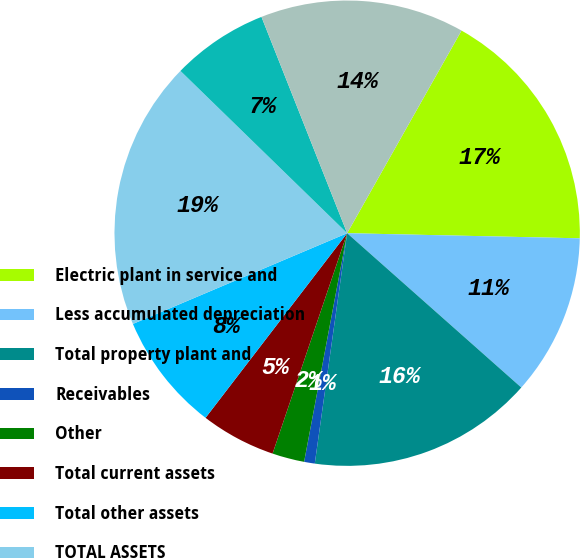Convert chart. <chart><loc_0><loc_0><loc_500><loc_500><pie_chart><fcel>Electric plant in service and<fcel>Less accumulated depreciation<fcel>Total property plant and<fcel>Receivables<fcel>Other<fcel>Total current assets<fcel>Total other assets<fcel>TOTAL ASSETS<fcel>Common shareholders' equity<fcel>Total capitalization<nl><fcel>17.17%<fcel>11.19%<fcel>15.68%<fcel>0.74%<fcel>2.23%<fcel>5.22%<fcel>8.21%<fcel>18.66%<fcel>6.71%<fcel>14.18%<nl></chart> 